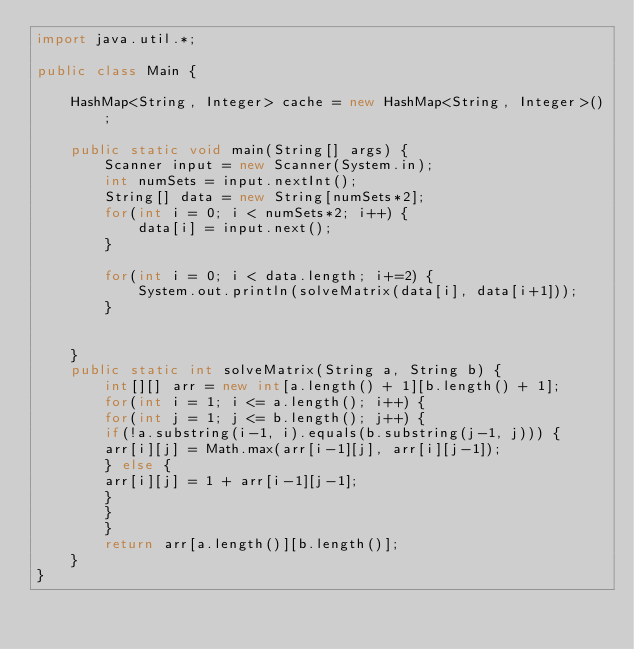Convert code to text. <code><loc_0><loc_0><loc_500><loc_500><_Java_>import java.util.*;

public class Main {
	
	HashMap<String, Integer> cache = new HashMap<String, Integer>();
	
	public static void main(String[] args) {
		Scanner input = new Scanner(System.in);
		int numSets = input.nextInt();
		String[] data = new String[numSets*2];
		for(int i = 0; i < numSets*2; i++) {
			data[i] = input.next();
		}
		
		for(int i = 0; i < data.length; i+=2) {
			System.out.println(solveMatrix(data[i], data[i+1]));
		}
		
		
	}
	public static int solveMatrix(String a, String b) {
		int[][] arr = new int[a.length() + 1][b.length() + 1];
		for(int i = 1; i <= a.length(); i++) {
		for(int j = 1; j <= b.length(); j++) {
		if(!a.substring(i-1, i).equals(b.substring(j-1, j))) {
		arr[i][j] = Math.max(arr[i-1][j], arr[i][j-1]);
		} else {
		arr[i][j] = 1 + arr[i-1][j-1];
		}
		}
		}
		return arr[a.length()][b.length()];
	}
}
</code> 